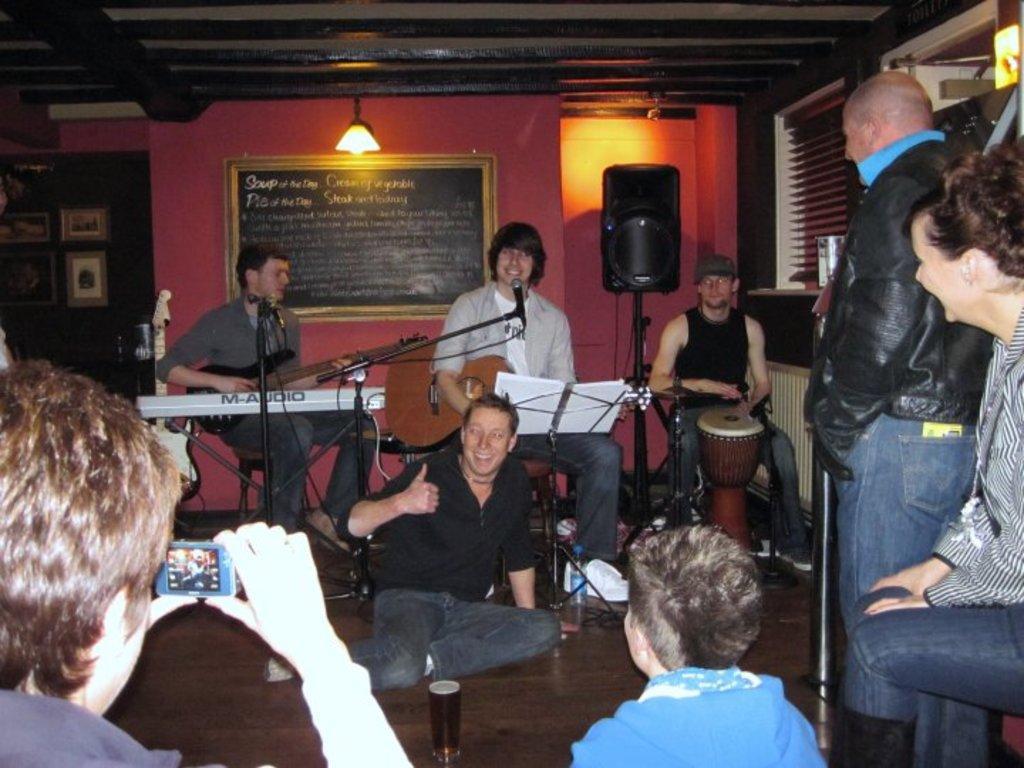How would you summarize this image in a sentence or two? Three men are performing in a live music and a man is posing to camera. 